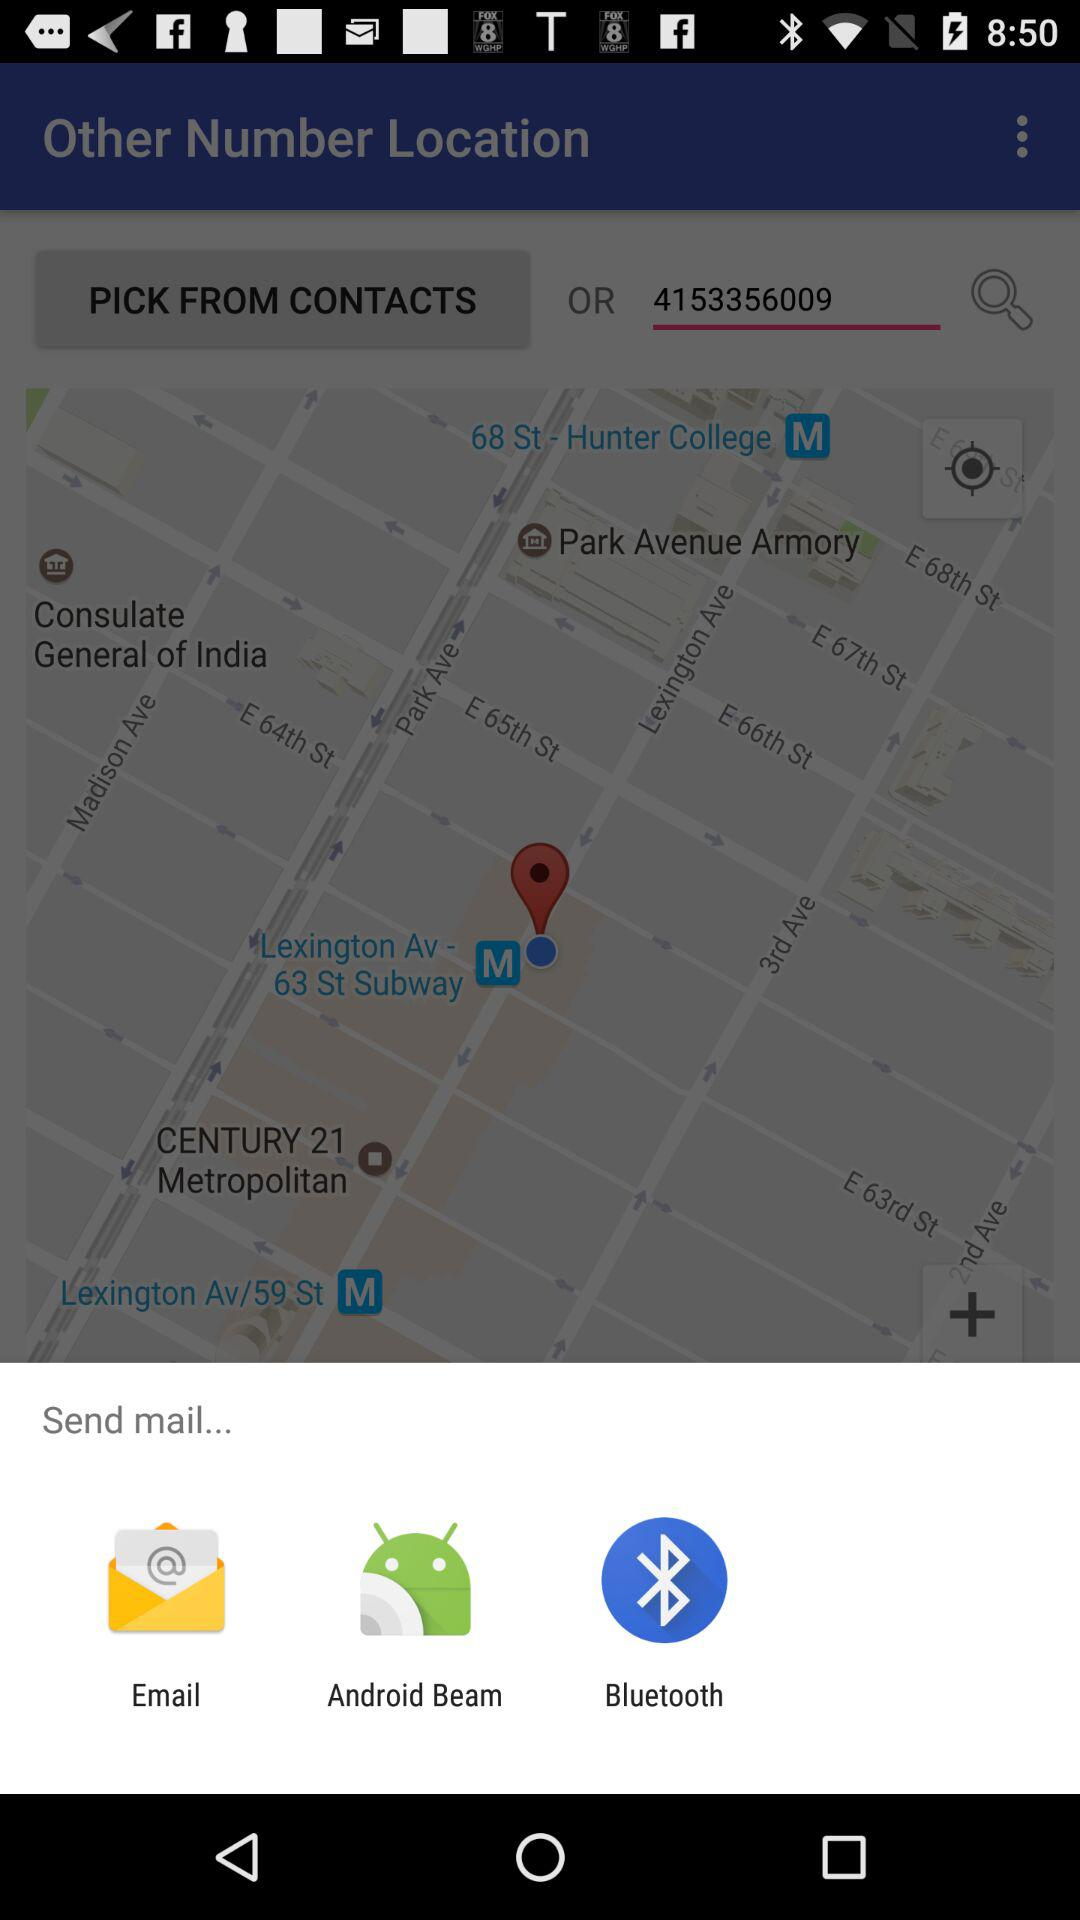What are the different applications through which we can send mail? The applications are "Email", "Android Beam" and "Bluetooth". 